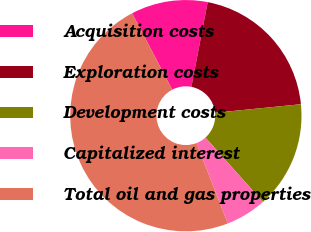Convert chart. <chart><loc_0><loc_0><loc_500><loc_500><pie_chart><fcel>Acquisition costs<fcel>Exploration costs<fcel>Development costs<fcel>Capitalized interest<fcel>Total oil and gas properties<nl><fcel>10.72%<fcel>20.39%<fcel>14.97%<fcel>5.7%<fcel>48.22%<nl></chart> 